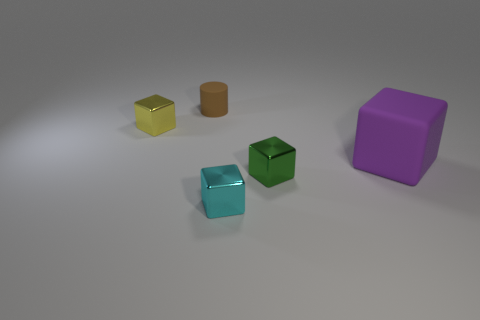Add 2 cyan metal things. How many objects exist? 7 Subtract all yellow cubes. How many cubes are left? 3 Subtract 2 cubes. How many cubes are left? 2 Subtract all cylinders. How many objects are left? 4 Subtract all green blocks. How many blocks are left? 3 Add 1 brown cylinders. How many brown cylinders exist? 2 Subtract 0 yellow cylinders. How many objects are left? 5 Subtract all purple blocks. Subtract all brown cylinders. How many blocks are left? 3 Subtract all red things. Subtract all tiny brown rubber objects. How many objects are left? 4 Add 5 tiny brown cylinders. How many tiny brown cylinders are left? 6 